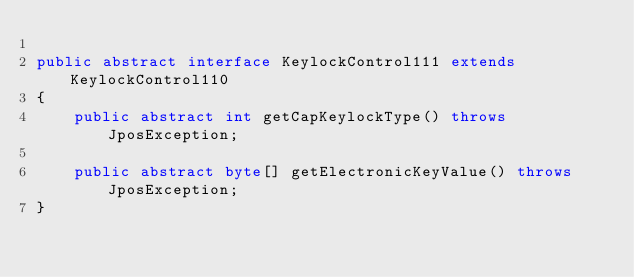<code> <loc_0><loc_0><loc_500><loc_500><_Java_>
public abstract interface KeylockControl111 extends KeylockControl110
{
	public abstract int getCapKeylockType() throws JposException;

	public abstract byte[] getElectronicKeyValue() throws JposException;
}
</code> 